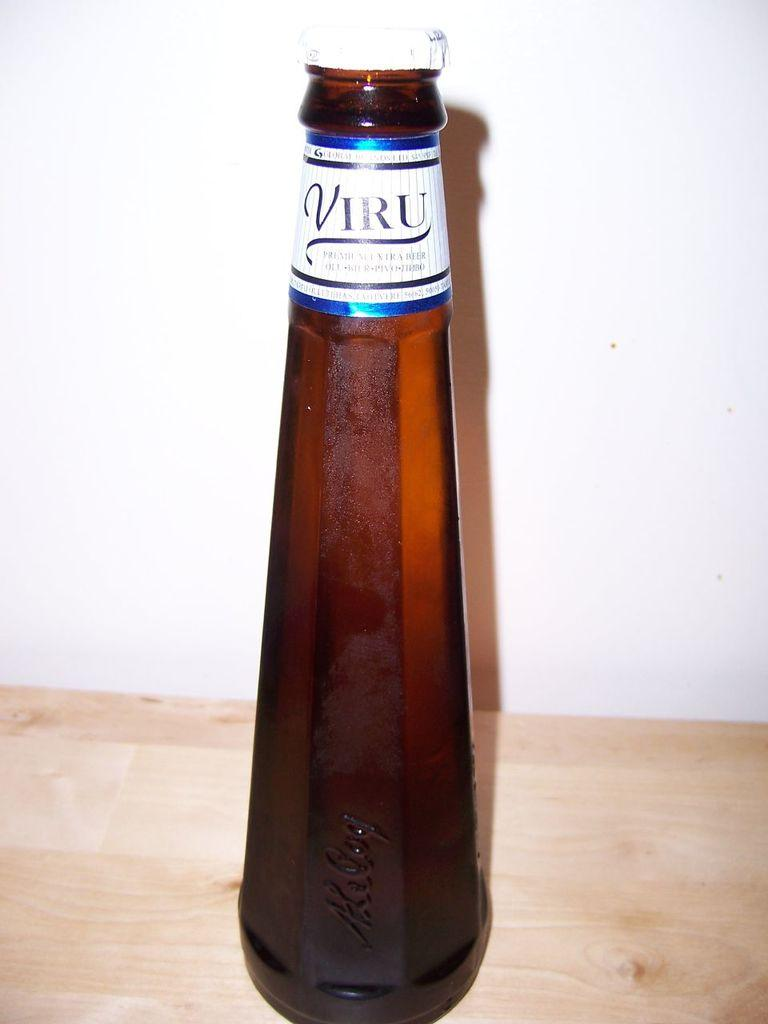What is the main object in the image? There is a bottle with a lid in the image. What can be seen on the bottle? The bottle has a label on it. Where is the bottle placed? The bottle is on a wooden board. What is visible in the background of the image? There is a wall in the background of the image. Can you see any air, planes, or boats in the image? No, there are no air, planes, or boats present in the image. 